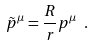<formula> <loc_0><loc_0><loc_500><loc_500>\tilde { p } ^ { \mu } = \frac { R } { r } p ^ { \mu } \ .</formula> 